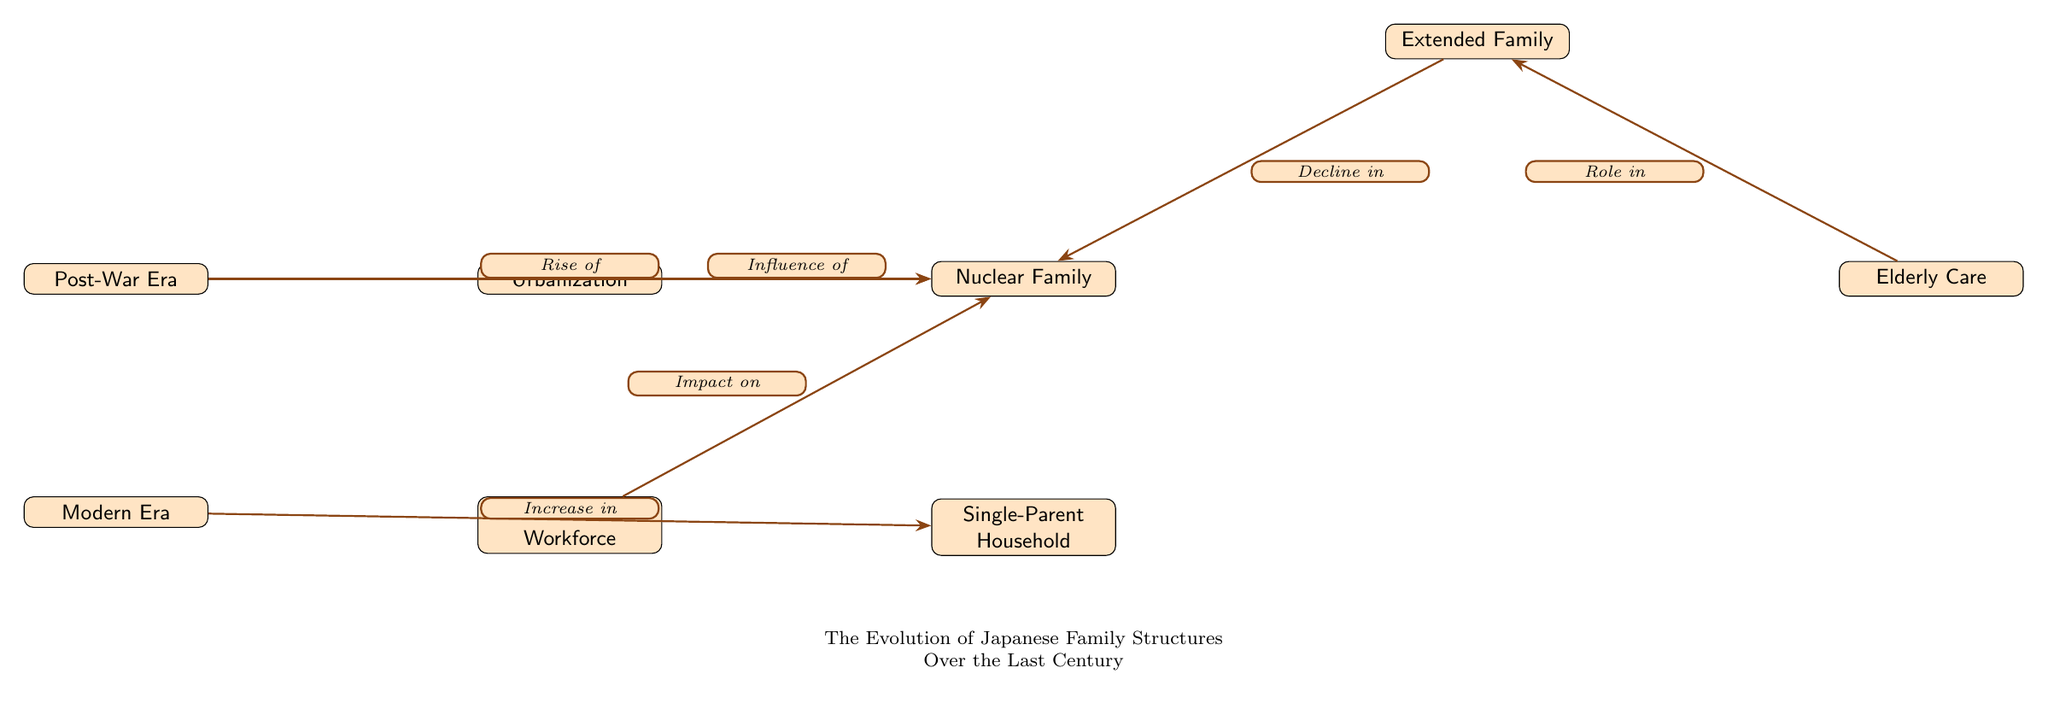What are the two main eras depicted in the diagram? The diagram clearly identifies the "Post-War Era" and "Modern Era" as the two main eras. They are positioned at the top and bottom of the diagram, respectively.
Answer: Post-War Era, Modern Era What is the relationship between urbanization and the nuclear family? The diagram illustrates that urbanization has a direct influence on the nuclear family. This relationship is represented by an arrow leading from the "Urbanization" node to the "Nuclear Family" node.
Answer: Influence of How many major family structures are represented in the diagram? Upon examining the diagram, there are five major family structures identified: Extended Family, Nuclear Family, Single-Parent Household, Elderly Care, and the impact of Women in Workforce. Counting all these nodes, we find a total of five distinct family structures.
Answer: 5 What leads to the increase in single-parent households? The diagram indicates that the "Modern Era" has an increase in single-parent households, denoted by the arrow stemming directly from the "Modern Era" node pointing to the "Single-Parent Household" node. Therefore, the increase is related to changes in family structures during the modern period.
Answer: Increase in Which family structure is affected by the rise of elderly care? The diagram shows an arrow from the "Elderly Care" node pointing to the "Extended Family" node, indicating that elderly care plays a role in the functioning or presence of extended families.
Answer: Extended Family What has happened to the extended family structure over time? The diagram shows that there is a decline in the extended family as it points toward the nuclear family. This suggests that while extended families were significant, they have diminished in favor of nuclear families over time.
Answer: Decline in How does the women workforce impact the nuclear family? According to the diagram, there is an arrow labeled "Impact on" from the "Women in Workforce" node to the "Nuclear Family" node, indicating that the presence of women in the workforce has a significant effect on the dynamics of nuclear families.
Answer: Impact on What type of social transformation does urbanization represent? Urbanization is represented in the diagram as a social transformation that influences the formation and characteristics of the nuclear family, suggesting changes in living arrangements and family dynamics due to urban development.
Answer: Influence of 